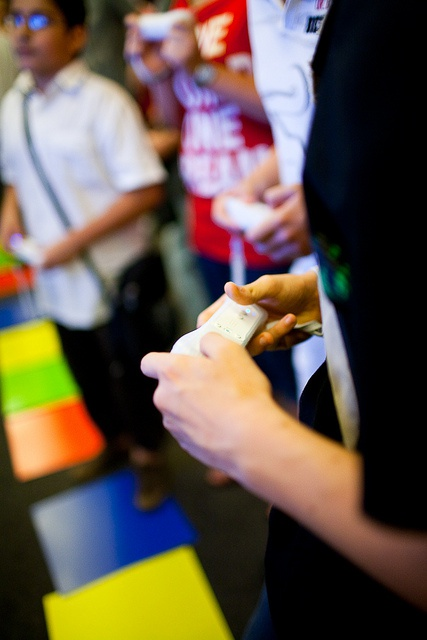Describe the objects in this image and their specific colors. I can see people in maroon, black, and tan tones, people in maroon, black, lavender, and darkgray tones, people in maroon, lavender, brown, and violet tones, people in maroon, lavender, lightpink, darkgray, and brown tones, and handbag in maroon, black, gray, and darkgray tones in this image. 